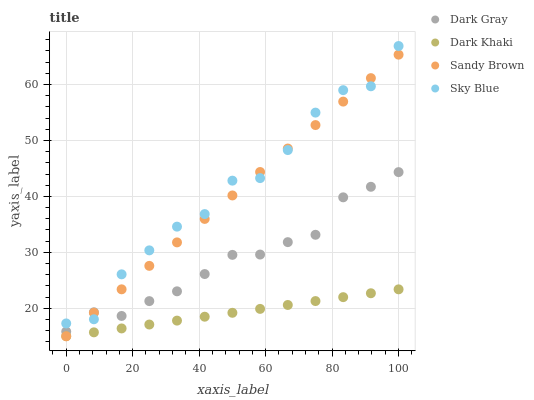Does Dark Khaki have the minimum area under the curve?
Answer yes or no. Yes. Does Sky Blue have the maximum area under the curve?
Answer yes or no. Yes. Does Sandy Brown have the minimum area under the curve?
Answer yes or no. No. Does Sandy Brown have the maximum area under the curve?
Answer yes or no. No. Is Dark Khaki the smoothest?
Answer yes or no. Yes. Is Sky Blue the roughest?
Answer yes or no. Yes. Is Sandy Brown the smoothest?
Answer yes or no. No. Is Sandy Brown the roughest?
Answer yes or no. No. Does Dark Khaki have the lowest value?
Answer yes or no. Yes. Does Sky Blue have the lowest value?
Answer yes or no. No. Does Sky Blue have the highest value?
Answer yes or no. Yes. Does Sandy Brown have the highest value?
Answer yes or no. No. Is Dark Khaki less than Sky Blue?
Answer yes or no. Yes. Is Dark Gray greater than Dark Khaki?
Answer yes or no. Yes. Does Sandy Brown intersect Dark Gray?
Answer yes or no. Yes. Is Sandy Brown less than Dark Gray?
Answer yes or no. No. Is Sandy Brown greater than Dark Gray?
Answer yes or no. No. Does Dark Khaki intersect Sky Blue?
Answer yes or no. No. 